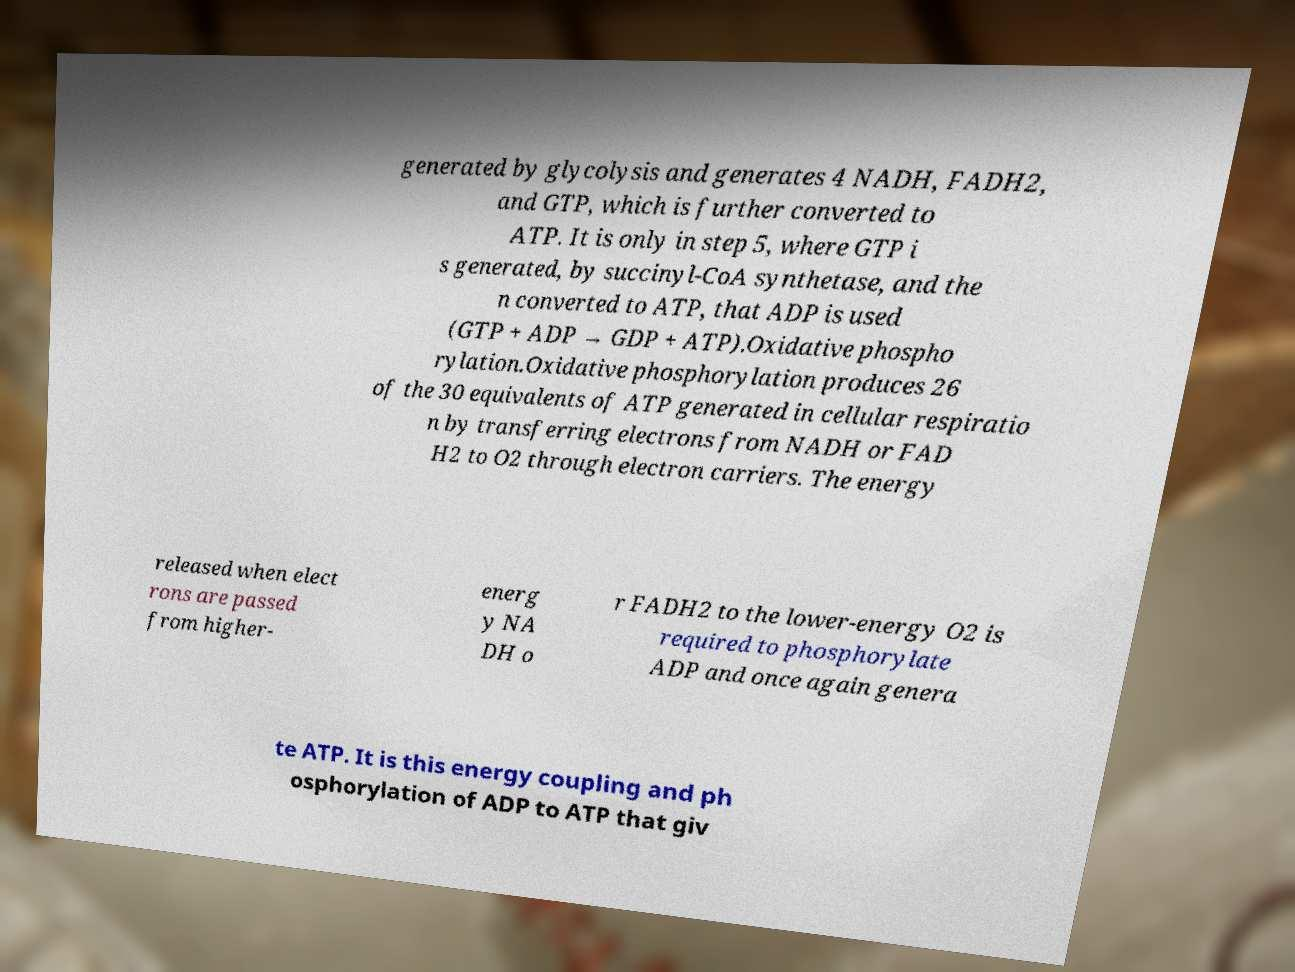I need the written content from this picture converted into text. Can you do that? generated by glycolysis and generates 4 NADH, FADH2, and GTP, which is further converted to ATP. It is only in step 5, where GTP i s generated, by succinyl-CoA synthetase, and the n converted to ATP, that ADP is used (GTP + ADP → GDP + ATP).Oxidative phospho rylation.Oxidative phosphorylation produces 26 of the 30 equivalents of ATP generated in cellular respiratio n by transferring electrons from NADH or FAD H2 to O2 through electron carriers. The energy released when elect rons are passed from higher- energ y NA DH o r FADH2 to the lower-energy O2 is required to phosphorylate ADP and once again genera te ATP. It is this energy coupling and ph osphorylation of ADP to ATP that giv 